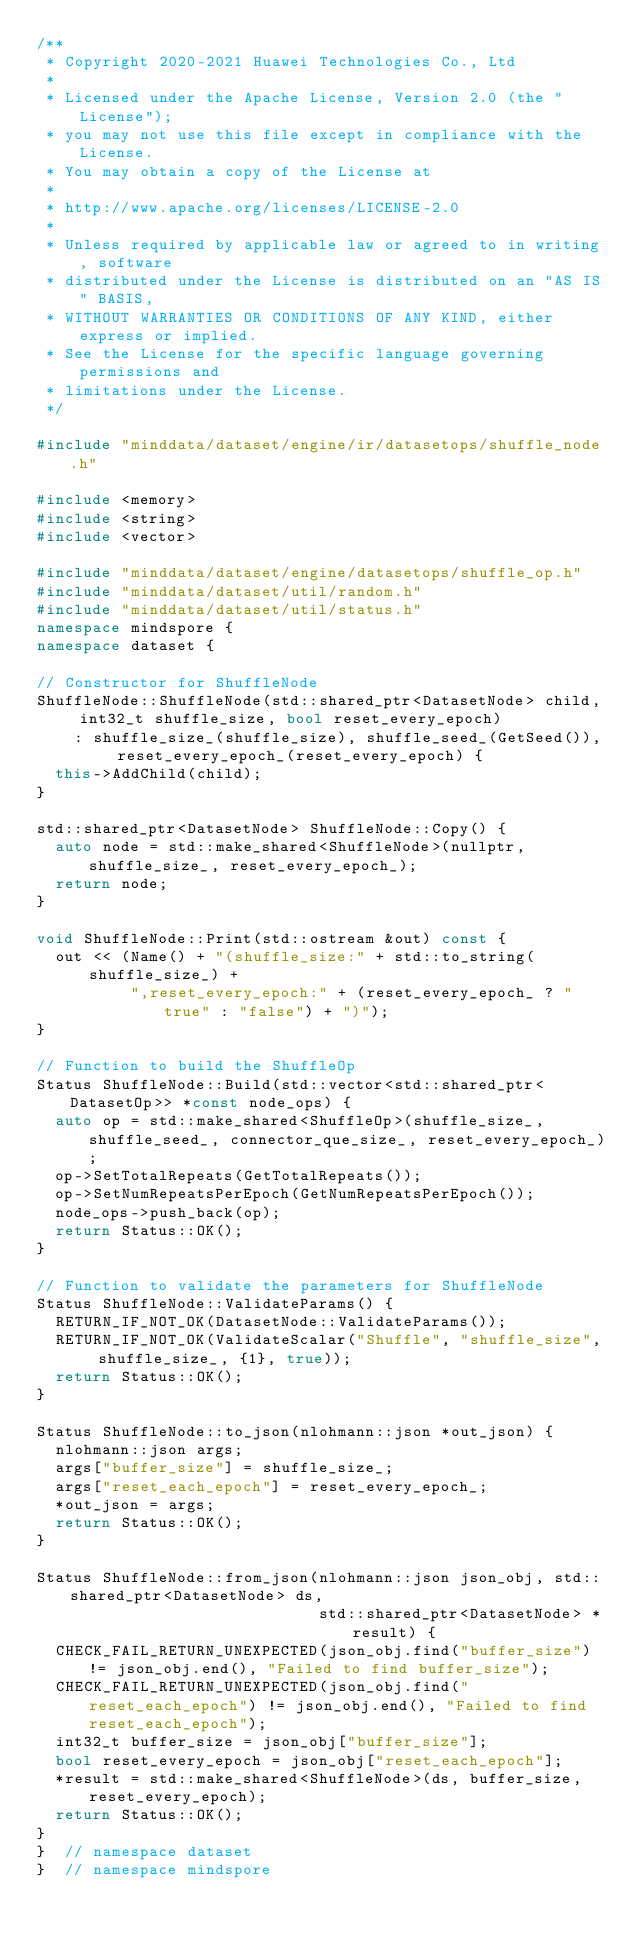<code> <loc_0><loc_0><loc_500><loc_500><_C++_>/**
 * Copyright 2020-2021 Huawei Technologies Co., Ltd
 *
 * Licensed under the Apache License, Version 2.0 (the "License");
 * you may not use this file except in compliance with the License.
 * You may obtain a copy of the License at
 *
 * http://www.apache.org/licenses/LICENSE-2.0
 *
 * Unless required by applicable law or agreed to in writing, software
 * distributed under the License is distributed on an "AS IS" BASIS,
 * WITHOUT WARRANTIES OR CONDITIONS OF ANY KIND, either express or implied.
 * See the License for the specific language governing permissions and
 * limitations under the License.
 */

#include "minddata/dataset/engine/ir/datasetops/shuffle_node.h"

#include <memory>
#include <string>
#include <vector>

#include "minddata/dataset/engine/datasetops/shuffle_op.h"
#include "minddata/dataset/util/random.h"
#include "minddata/dataset/util/status.h"
namespace mindspore {
namespace dataset {

// Constructor for ShuffleNode
ShuffleNode::ShuffleNode(std::shared_ptr<DatasetNode> child, int32_t shuffle_size, bool reset_every_epoch)
    : shuffle_size_(shuffle_size), shuffle_seed_(GetSeed()), reset_every_epoch_(reset_every_epoch) {
  this->AddChild(child);
}

std::shared_ptr<DatasetNode> ShuffleNode::Copy() {
  auto node = std::make_shared<ShuffleNode>(nullptr, shuffle_size_, reset_every_epoch_);
  return node;
}

void ShuffleNode::Print(std::ostream &out) const {
  out << (Name() + "(shuffle_size:" + std::to_string(shuffle_size_) +
          ",reset_every_epoch:" + (reset_every_epoch_ ? "true" : "false") + ")");
}

// Function to build the ShuffleOp
Status ShuffleNode::Build(std::vector<std::shared_ptr<DatasetOp>> *const node_ops) {
  auto op = std::make_shared<ShuffleOp>(shuffle_size_, shuffle_seed_, connector_que_size_, reset_every_epoch_);
  op->SetTotalRepeats(GetTotalRepeats());
  op->SetNumRepeatsPerEpoch(GetNumRepeatsPerEpoch());
  node_ops->push_back(op);
  return Status::OK();
}

// Function to validate the parameters for ShuffleNode
Status ShuffleNode::ValidateParams() {
  RETURN_IF_NOT_OK(DatasetNode::ValidateParams());
  RETURN_IF_NOT_OK(ValidateScalar("Shuffle", "shuffle_size", shuffle_size_, {1}, true));
  return Status::OK();
}

Status ShuffleNode::to_json(nlohmann::json *out_json) {
  nlohmann::json args;
  args["buffer_size"] = shuffle_size_;
  args["reset_each_epoch"] = reset_every_epoch_;
  *out_json = args;
  return Status::OK();
}

Status ShuffleNode::from_json(nlohmann::json json_obj, std::shared_ptr<DatasetNode> ds,
                              std::shared_ptr<DatasetNode> *result) {
  CHECK_FAIL_RETURN_UNEXPECTED(json_obj.find("buffer_size") != json_obj.end(), "Failed to find buffer_size");
  CHECK_FAIL_RETURN_UNEXPECTED(json_obj.find("reset_each_epoch") != json_obj.end(), "Failed to find reset_each_epoch");
  int32_t buffer_size = json_obj["buffer_size"];
  bool reset_every_epoch = json_obj["reset_each_epoch"];
  *result = std::make_shared<ShuffleNode>(ds, buffer_size, reset_every_epoch);
  return Status::OK();
}
}  // namespace dataset
}  // namespace mindspore
</code> 